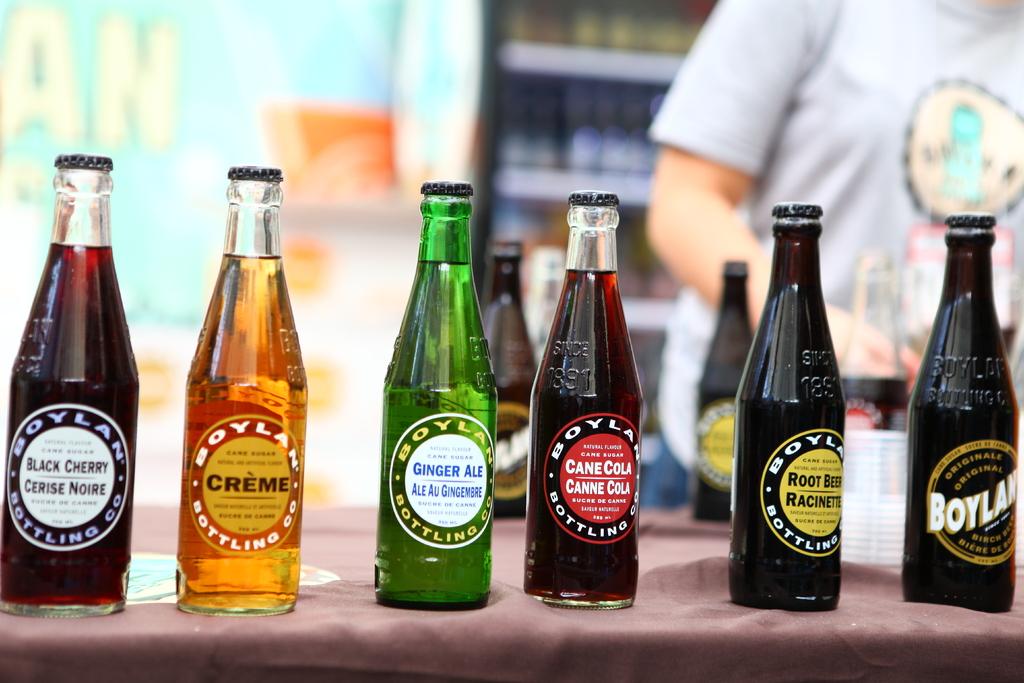What is the beverage on the left?
Your answer should be very brief. Black cherry. 